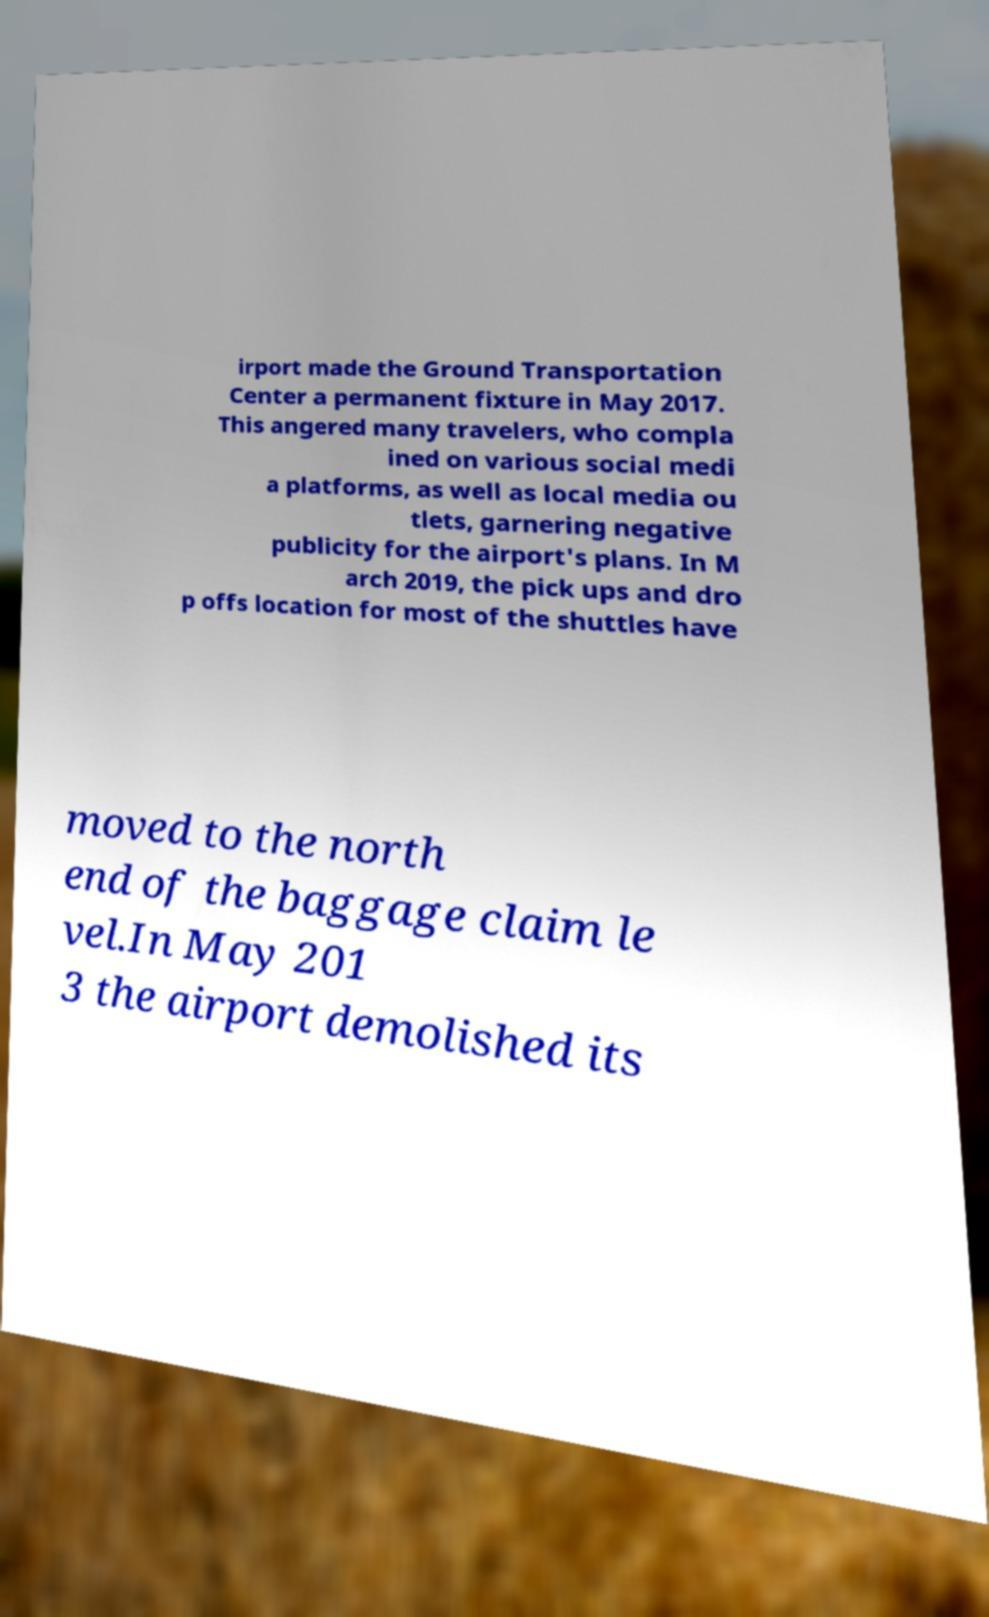Please read and relay the text visible in this image. What does it say? irport made the Ground Transportation Center a permanent fixture in May 2017. This angered many travelers, who compla ined on various social medi a platforms, as well as local media ou tlets, garnering negative publicity for the airport's plans. In M arch 2019, the pick ups and dro p offs location for most of the shuttles have moved to the north end of the baggage claim le vel.In May 201 3 the airport demolished its 